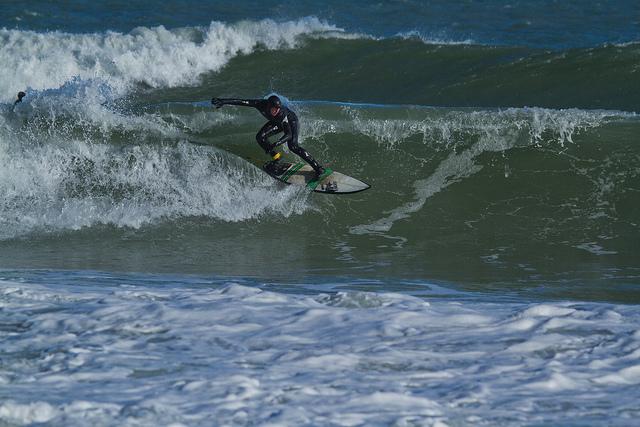How high in the air is he?
Answer briefly. Not high. Are there waves?
Write a very short answer. Yes. Is this surfing?
Give a very brief answer. Yes. How many surfers are in the picture?
Concise answer only. 1. Which arm is the surfer holding straight out?
Write a very short answer. Right. 